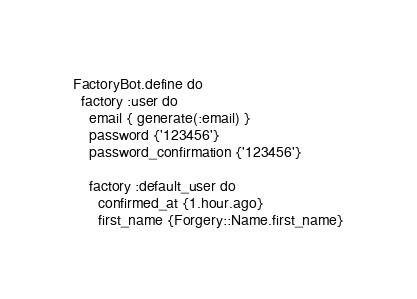Convert code to text. <code><loc_0><loc_0><loc_500><loc_500><_Ruby_>FactoryBot.define do
  factory :user do
    email { generate(:email) }
    password {'123456'}
    password_confirmation {'123456'}

    factory :default_user do
      confirmed_at {1.hour.ago}
      first_name {Forgery::Name.first_name}</code> 